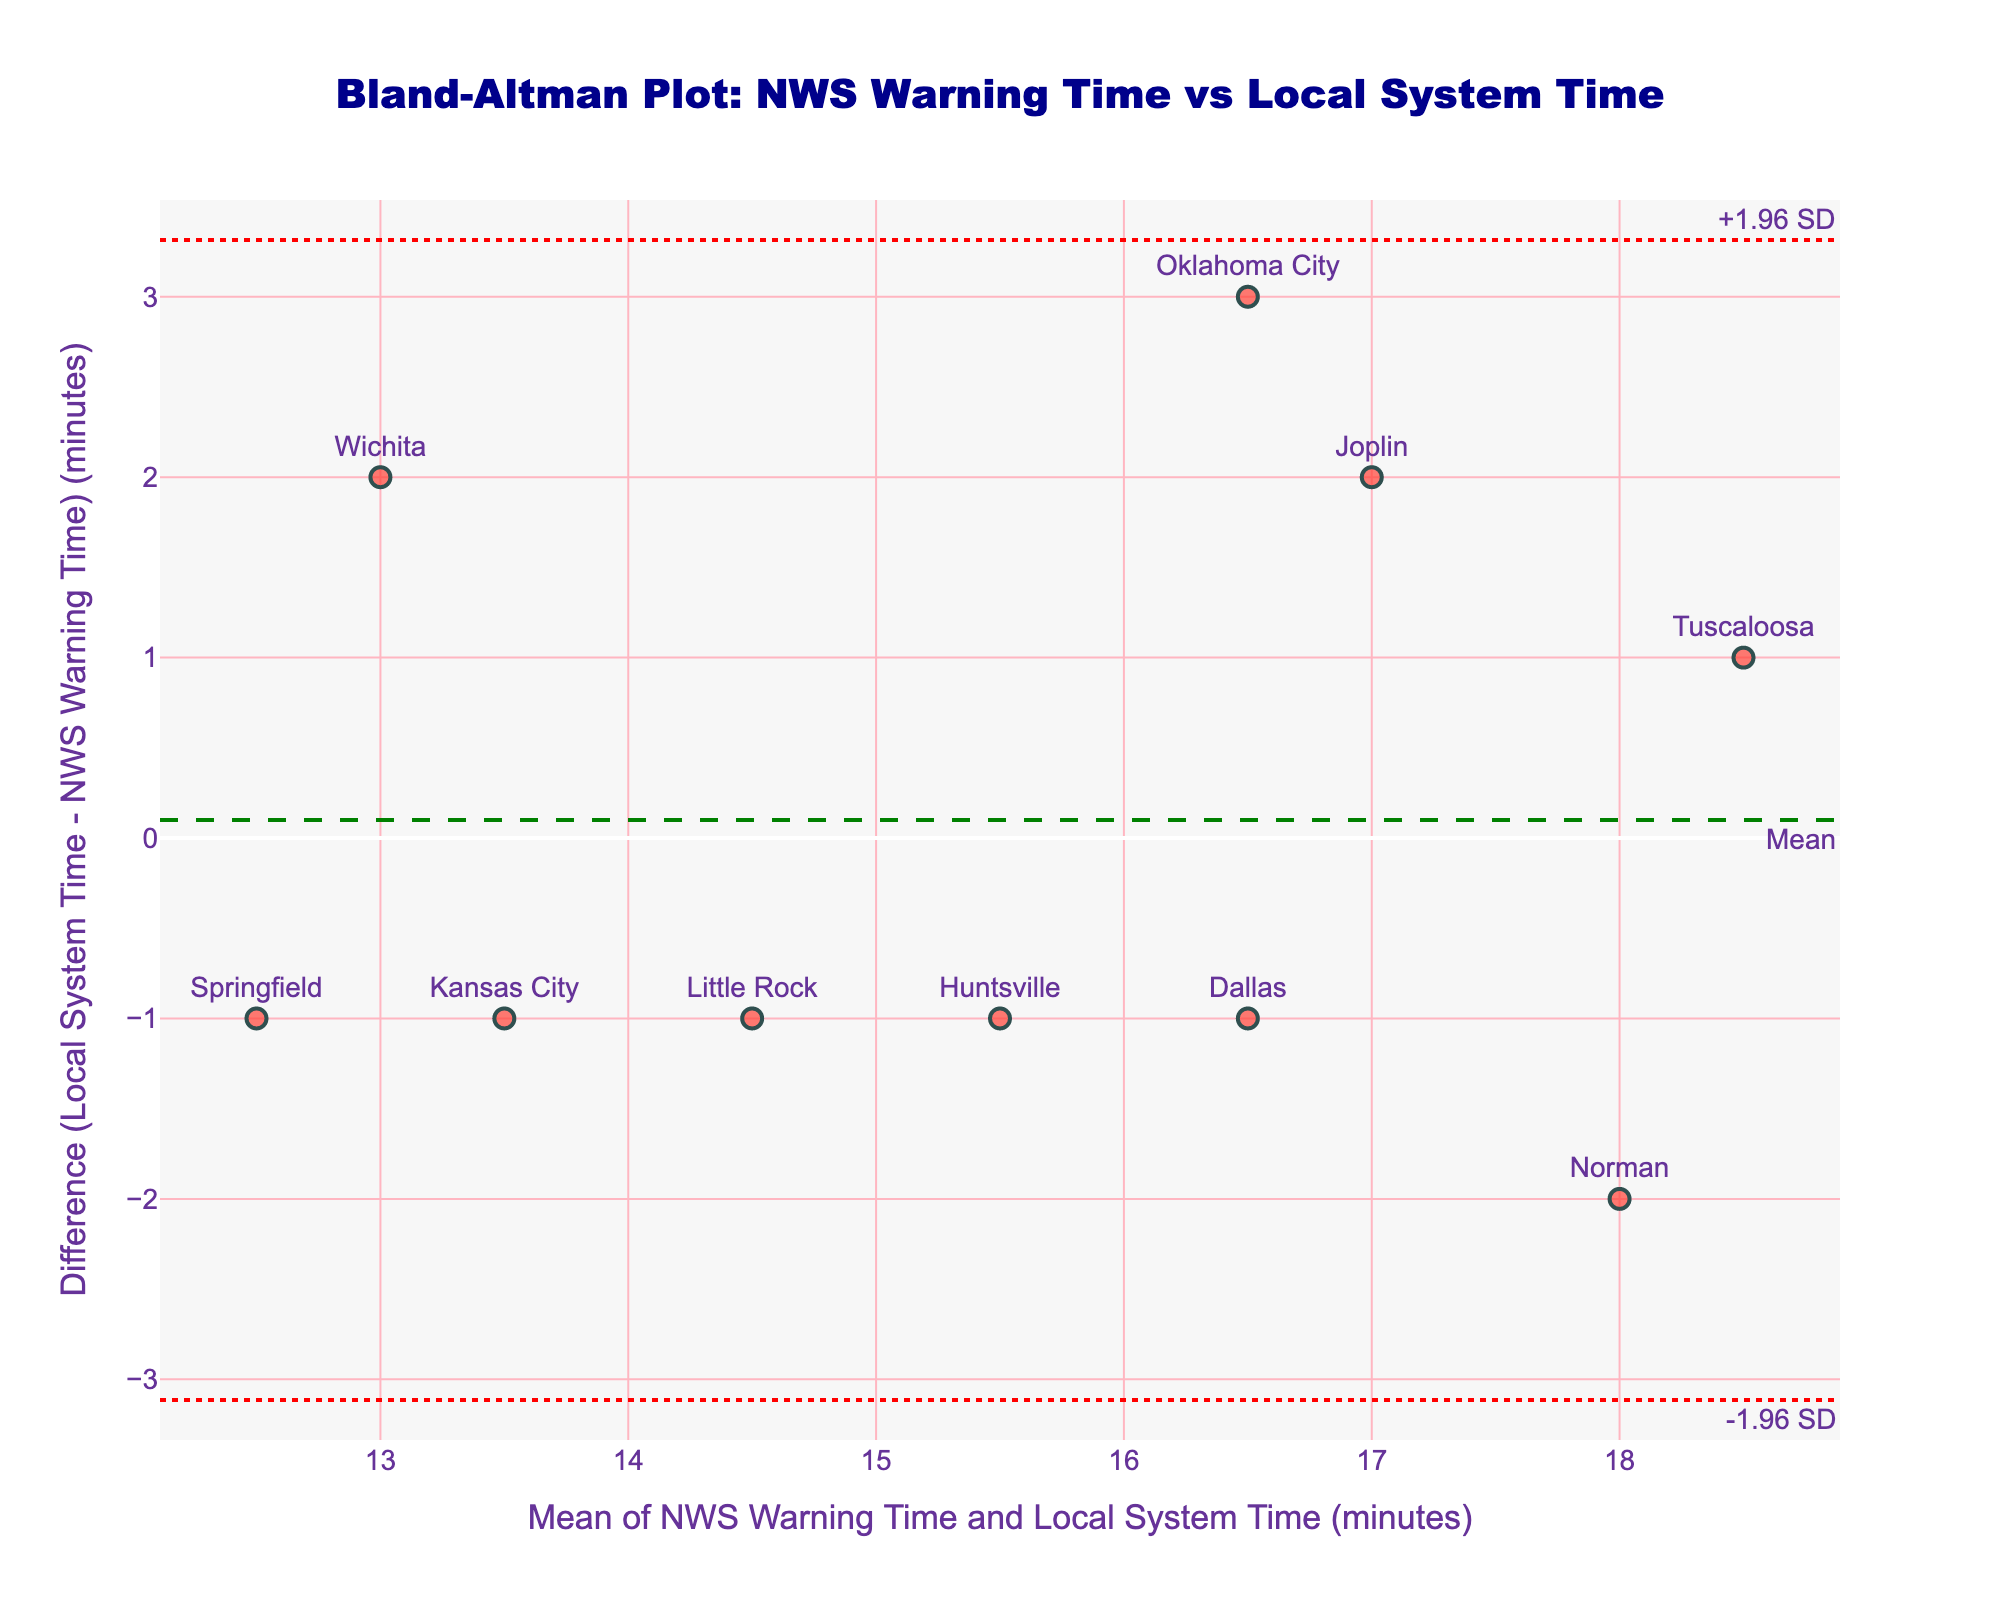Which city corresponds to the data point closest to the mean difference line? The mean difference line is the horizontal green dashed line. The data point nearest to this line would have the smallest vertical distance from it.
Answer: Dallas What is the difference in warning time for Norman? Locate Norman in the scatter plot, then find the vertical distance from its point to the x-axis. The y-value of this point represents the difference in warning times.
Answer: -2 minutes What does the red dotted line above the mean difference represent? In a Bland–Altman plot, the upper red dotted line represents the upper limit of agreement, which is mean difference + 1.96 times the standard deviation of the differences.
Answer: Upper limit of agreement Which location has the highest positive difference in warning times? Look for the highest data point (greatest vertical distance above the x-axis) on the plot. This point represents the largest positive difference in warning times.
Answer: Joplin Are there any data points that fall outside the limits of agreement? Check if any data points are above or below the red dotted lines representing the limits of agreement. If no points cross these lines, then none are outside the limits.
Answer: No What is the mean of the warning times for the SAILS Algorithm and NEXRAD Doppler Radar? Calculate the average of NWS and Local System times for both methods and then find their mean: SAILS (15 + 14)/2 and NEXRAD (15 + 18)/2, averaging these two values.
Answer: (14.5 + 16.5)/2 = 15.5 minutes How many locations show a negative difference in warning times? Count the data points positioned below the x-axis (those with negative y-values), as these represent negative differences.
Answer: 6 locations Which method has a mean warning time closest to 15 minutes? Calculate the mean warning time for each method and compare them to find which is nearest to 15 minutes.
Answer: SAILS Algorithm Which city has the greatest discrepancy between NWS and local system warning times? Identify the point with the largest absolute difference from the x-axis (either above or below).
Answer: Joplin 